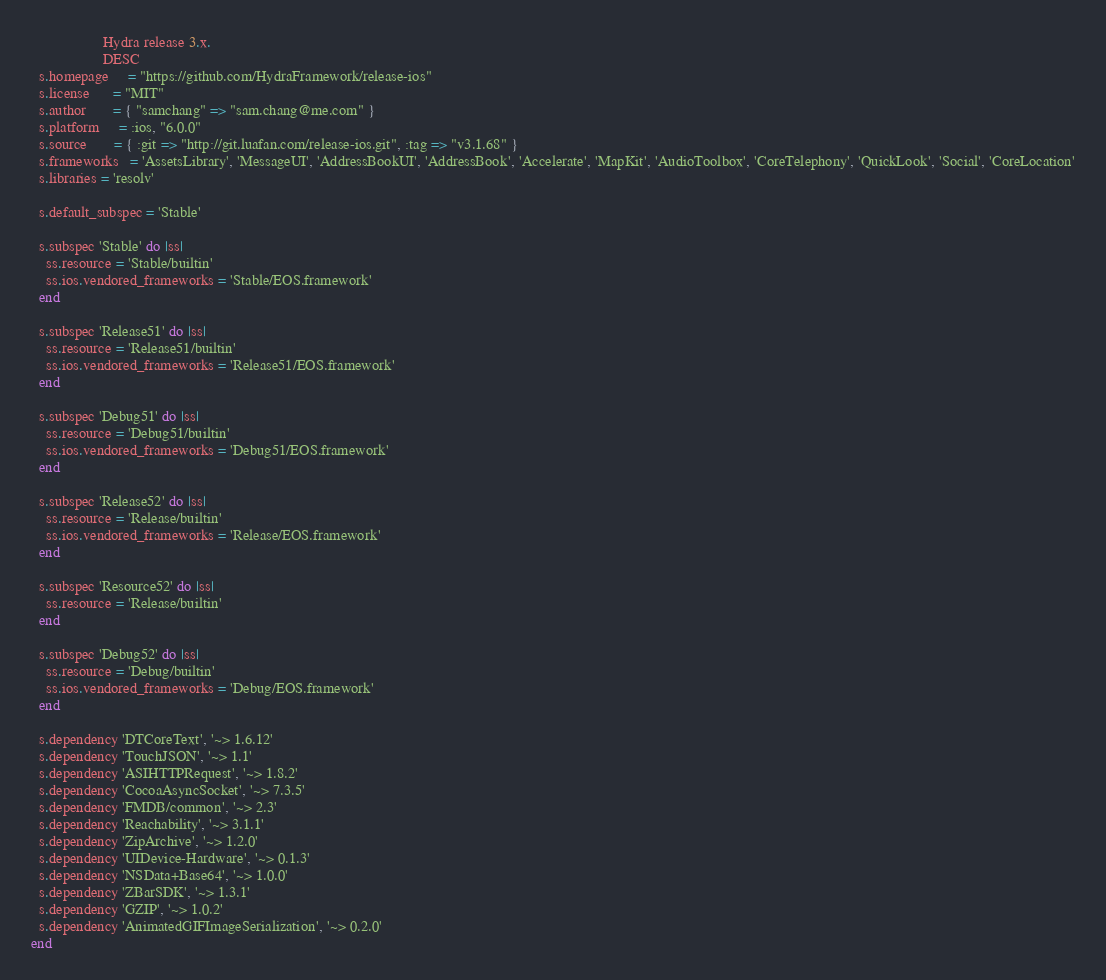Convert code to text. <code><loc_0><loc_0><loc_500><loc_500><_Ruby_>                   Hydra release 3.x.
                   DESC
  s.homepage     = "https://github.com/HydraFramework/release-ios"
  s.license      = "MIT"
  s.author       = { "samchang" => "sam.chang@me.com" }
  s.platform     = :ios, "6.0.0"
  s.source       = { :git => "http://git.luafan.com/release-ios.git", :tag => "v3.1.68" }
  s.frameworks   = 'AssetsLibrary', 'MessageUI', 'AddressBookUI', 'AddressBook', 'Accelerate', 'MapKit', 'AudioToolbox', 'CoreTelephony', 'QuickLook', 'Social', 'CoreLocation'
  s.libraries = 'resolv'

  s.default_subspec = 'Stable'

  s.subspec 'Stable' do |ss|
    ss.resource = 'Stable/builtin'
    ss.ios.vendored_frameworks = 'Stable/EOS.framework'
  end

  s.subspec 'Release51' do |ss|
    ss.resource = 'Release51/builtin'
    ss.ios.vendored_frameworks = 'Release51/EOS.framework'
  end

  s.subspec 'Debug51' do |ss|
    ss.resource = 'Debug51/builtin'
    ss.ios.vendored_frameworks = 'Debug51/EOS.framework'
  end

  s.subspec 'Release52' do |ss|
    ss.resource = 'Release/builtin'
    ss.ios.vendored_frameworks = 'Release/EOS.framework'
  end

  s.subspec 'Resource52' do |ss|
    ss.resource = 'Release/builtin'
  end

  s.subspec 'Debug52' do |ss|
    ss.resource = 'Debug/builtin'
    ss.ios.vendored_frameworks = 'Debug/EOS.framework'
  end

  s.dependency 'DTCoreText', '~> 1.6.12'
  s.dependency 'TouchJSON', '~> 1.1'
  s.dependency 'ASIHTTPRequest', '~> 1.8.2'
  s.dependency 'CocoaAsyncSocket', '~> 7.3.5'
  s.dependency 'FMDB/common', '~> 2.3'
  s.dependency 'Reachability', '~> 3.1.1'
  s.dependency 'ZipArchive', '~> 1.2.0'
  s.dependency 'UIDevice-Hardware', '~> 0.1.3'
  s.dependency 'NSData+Base64', '~> 1.0.0'
  s.dependency 'ZBarSDK', '~> 1.3.1'
  s.dependency 'GZIP', '~> 1.0.2'
  s.dependency 'AnimatedGIFImageSerialization', '~> 0.2.0'
end
</code> 